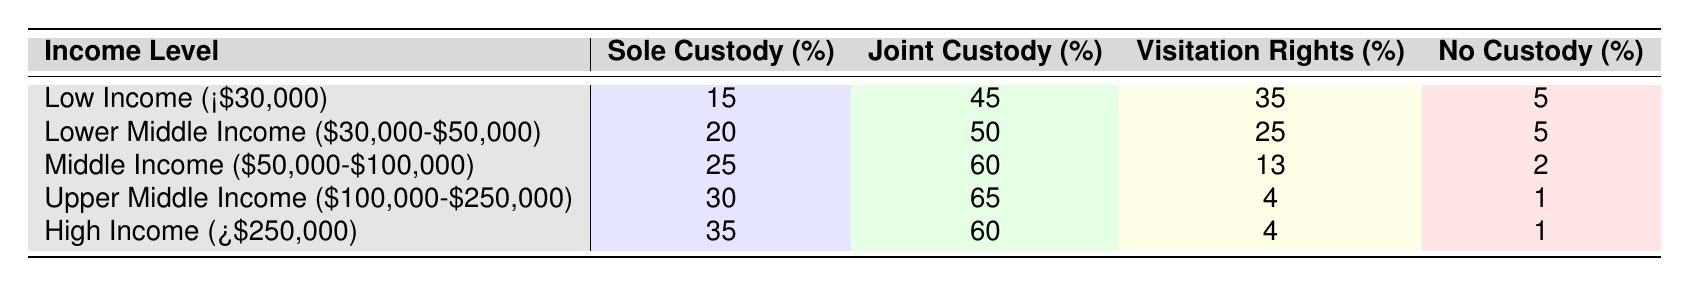What percentage of high-income parents receive sole custody? The table shows that high-income parents (those earning over $250,000) have a sole custody rate of 35%.
Answer: 35% What is the difference in sole custody percentage between low-income and middle-income parents? The sole custody percentage for low-income parents is 15%, and for middle-income parents, it is 25%. The difference is 25% - 15% = 10%.
Answer: 10% For which income level is joint custody the highest? According to the table, upper middle income ($100,000-$250,000) has the highest joint custody percentage at 65%.
Answer: Upper Middle Income Is it true that lower middle-income parents have more visitation rights than middle-income parents? The lower middle-income parents have 25% of visitation rights, whereas middle-income parents have 13%. Therefore, it is true that lower middle-income parents have more visitation rights.
Answer: Yes What percentage of parents in the middle-income group do not have custody? The table states that the percentage of middle-income parents with no custody is 2%.
Answer: 2% If you consider all parents, which income level has the lowest percentage of no custody? The table indicates that both upper middle income and high income groups have the same lowest percentage of no custody, which is 1%.
Answer: Upper Middle Income and High Income Calculate the average percentage of joint custody across all income levels. The joint custody percentages for the income levels are: 45%, 50%, 60%, 65%, and 60%. To find the average: (45 + 50 + 60 + 65 + 60) / 5 = 54%.
Answer: 54% Which income class sees a decline in visitation rights as income increases? Looking at the data, the visitation rights percentage decreases from 35% in low income to 4% in upper middle income and high income. Hence, visitation rights decline as income increases.
Answer: Yes What is the relationship between income level and sole custody percentage based on the table? As the income level increases, the percentage of sole custody increases from 15% in low income to 35% in high income, indicating a positive correlation between income and sole custody.
Answer: Positive correlation How many total parents are predicted to have joint custody if we consider all income groups? You would need the total number of parents in each group to calculate this, but if we use the percentages alone, the computed percentage is out of 100%. However, given the percentages, it can be said that multiple levels have joint custody percentages.
Answer: Cannot determine without total parent count Which income group has the lowest rate of sole custody? The low-income group has the lowest sole custody rate at 15%.
Answer: Low Income 